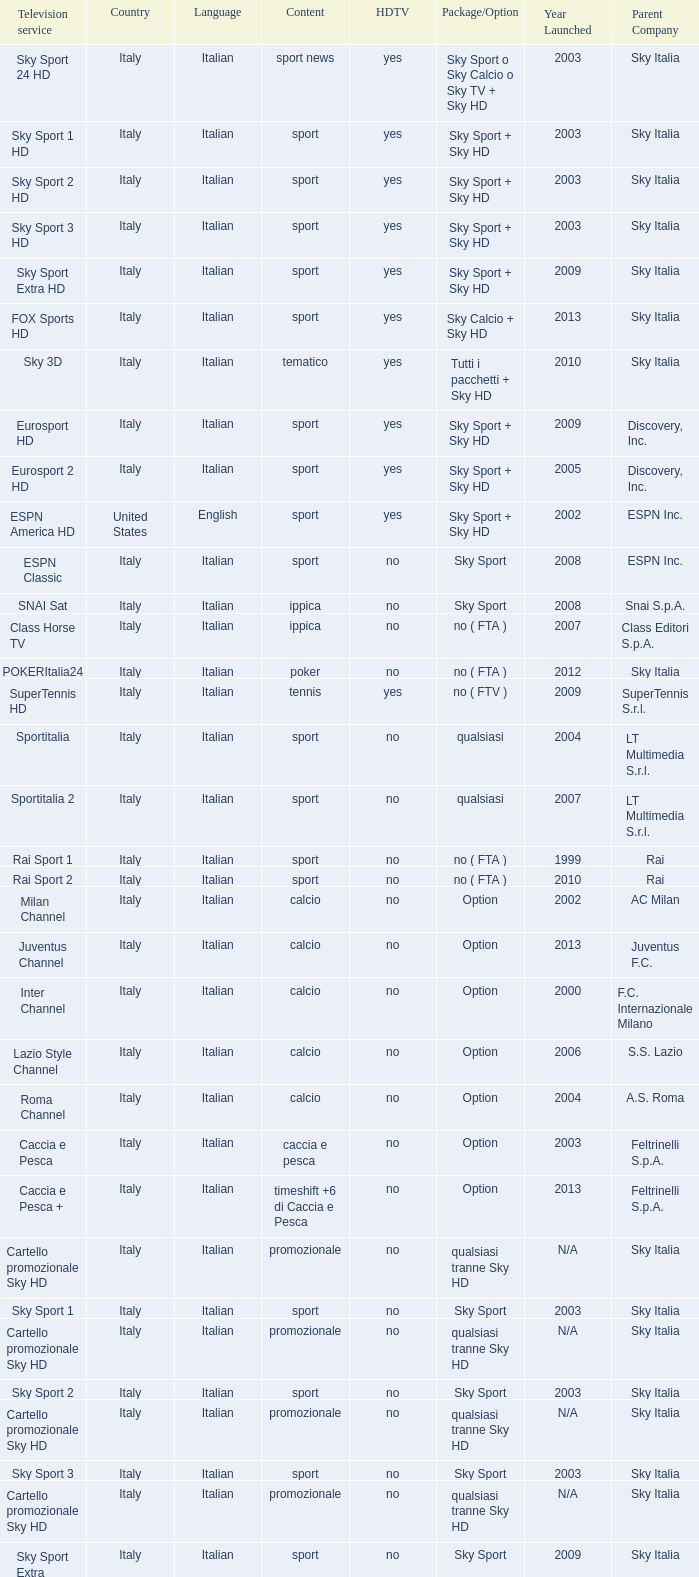What is the bundle/choice, when subject is tennis? No ( ftv ). 